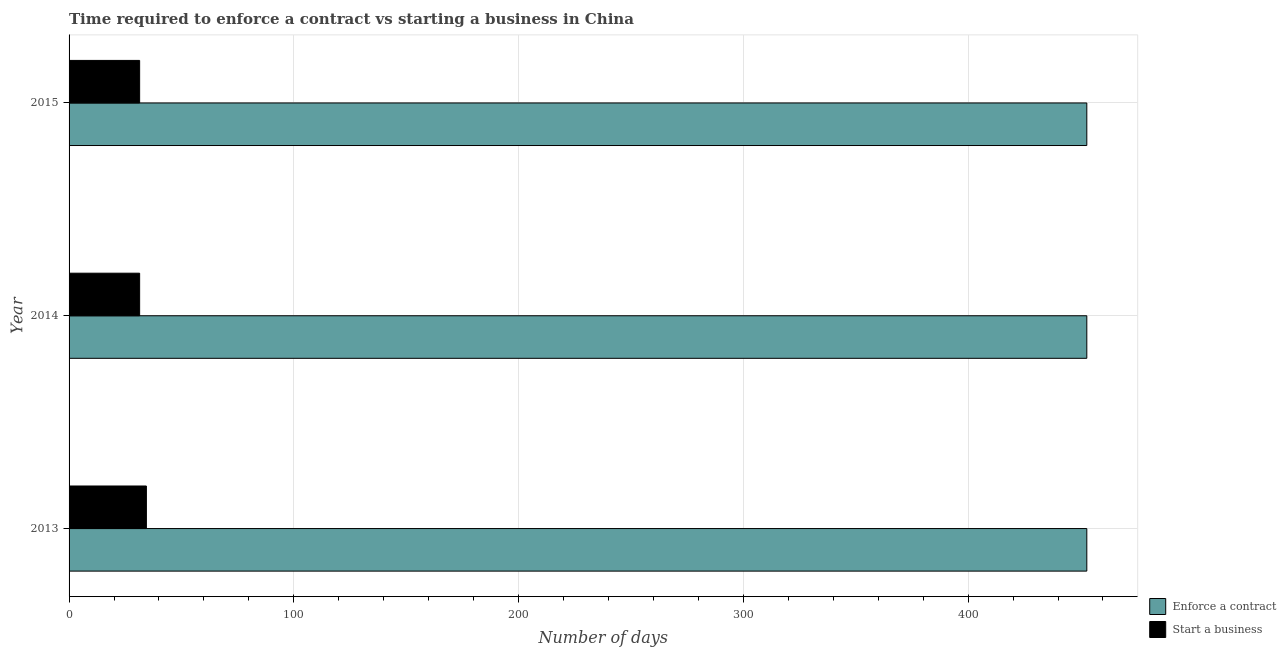How many groups of bars are there?
Your answer should be compact. 3. Are the number of bars per tick equal to the number of legend labels?
Your answer should be compact. Yes. How many bars are there on the 3rd tick from the top?
Make the answer very short. 2. What is the label of the 1st group of bars from the top?
Your answer should be compact. 2015. In how many cases, is the number of bars for a given year not equal to the number of legend labels?
Your answer should be very brief. 0. What is the number of days to enforece a contract in 2013?
Provide a short and direct response. 452.8. Across all years, what is the maximum number of days to start a business?
Your answer should be compact. 34.4. Across all years, what is the minimum number of days to start a business?
Your answer should be compact. 31.4. In which year was the number of days to start a business maximum?
Your answer should be very brief. 2013. In which year was the number of days to start a business minimum?
Provide a short and direct response. 2014. What is the total number of days to enforece a contract in the graph?
Provide a short and direct response. 1358.4. What is the difference between the number of days to start a business in 2013 and that in 2015?
Make the answer very short. 3. What is the difference between the number of days to start a business in 2014 and the number of days to enforece a contract in 2013?
Your answer should be compact. -421.4. What is the average number of days to enforece a contract per year?
Give a very brief answer. 452.8. In the year 2014, what is the difference between the number of days to enforece a contract and number of days to start a business?
Provide a succinct answer. 421.4. Is the number of days to start a business in 2013 less than that in 2015?
Ensure brevity in your answer.  No. Is the difference between the number of days to enforece a contract in 2013 and 2014 greater than the difference between the number of days to start a business in 2013 and 2014?
Offer a terse response. No. What is the difference between the highest and the second highest number of days to start a business?
Your response must be concise. 3. What is the difference between the highest and the lowest number of days to start a business?
Offer a terse response. 3. Is the sum of the number of days to enforece a contract in 2013 and 2015 greater than the maximum number of days to start a business across all years?
Offer a very short reply. Yes. What does the 2nd bar from the top in 2014 represents?
Keep it short and to the point. Enforce a contract. What does the 2nd bar from the bottom in 2015 represents?
Your answer should be very brief. Start a business. Are all the bars in the graph horizontal?
Your response must be concise. Yes. Does the graph contain grids?
Your answer should be very brief. Yes. Where does the legend appear in the graph?
Offer a terse response. Bottom right. How many legend labels are there?
Your answer should be very brief. 2. What is the title of the graph?
Your response must be concise. Time required to enforce a contract vs starting a business in China. Does "DAC donors" appear as one of the legend labels in the graph?
Offer a terse response. No. What is the label or title of the X-axis?
Your response must be concise. Number of days. What is the label or title of the Y-axis?
Provide a succinct answer. Year. What is the Number of days in Enforce a contract in 2013?
Provide a short and direct response. 452.8. What is the Number of days in Start a business in 2013?
Your answer should be compact. 34.4. What is the Number of days of Enforce a contract in 2014?
Your response must be concise. 452.8. What is the Number of days in Start a business in 2014?
Your response must be concise. 31.4. What is the Number of days in Enforce a contract in 2015?
Your answer should be very brief. 452.8. What is the Number of days of Start a business in 2015?
Offer a very short reply. 31.4. Across all years, what is the maximum Number of days of Enforce a contract?
Ensure brevity in your answer.  452.8. Across all years, what is the maximum Number of days in Start a business?
Offer a terse response. 34.4. Across all years, what is the minimum Number of days of Enforce a contract?
Ensure brevity in your answer.  452.8. Across all years, what is the minimum Number of days of Start a business?
Offer a very short reply. 31.4. What is the total Number of days in Enforce a contract in the graph?
Your response must be concise. 1358.4. What is the total Number of days of Start a business in the graph?
Offer a terse response. 97.2. What is the difference between the Number of days of Enforce a contract in 2013 and that in 2014?
Offer a very short reply. 0. What is the difference between the Number of days of Start a business in 2013 and that in 2014?
Your answer should be very brief. 3. What is the difference between the Number of days in Enforce a contract in 2013 and that in 2015?
Offer a terse response. 0. What is the difference between the Number of days in Enforce a contract in 2013 and the Number of days in Start a business in 2014?
Your answer should be compact. 421.4. What is the difference between the Number of days in Enforce a contract in 2013 and the Number of days in Start a business in 2015?
Offer a very short reply. 421.4. What is the difference between the Number of days of Enforce a contract in 2014 and the Number of days of Start a business in 2015?
Keep it short and to the point. 421.4. What is the average Number of days in Enforce a contract per year?
Your response must be concise. 452.8. What is the average Number of days of Start a business per year?
Offer a terse response. 32.4. In the year 2013, what is the difference between the Number of days of Enforce a contract and Number of days of Start a business?
Your answer should be compact. 418.4. In the year 2014, what is the difference between the Number of days in Enforce a contract and Number of days in Start a business?
Offer a very short reply. 421.4. In the year 2015, what is the difference between the Number of days of Enforce a contract and Number of days of Start a business?
Your answer should be very brief. 421.4. What is the ratio of the Number of days in Enforce a contract in 2013 to that in 2014?
Give a very brief answer. 1. What is the ratio of the Number of days of Start a business in 2013 to that in 2014?
Provide a short and direct response. 1.1. What is the ratio of the Number of days of Start a business in 2013 to that in 2015?
Keep it short and to the point. 1.1. What is the ratio of the Number of days of Start a business in 2014 to that in 2015?
Offer a terse response. 1. What is the difference between the highest and the second highest Number of days in Enforce a contract?
Give a very brief answer. 0. 